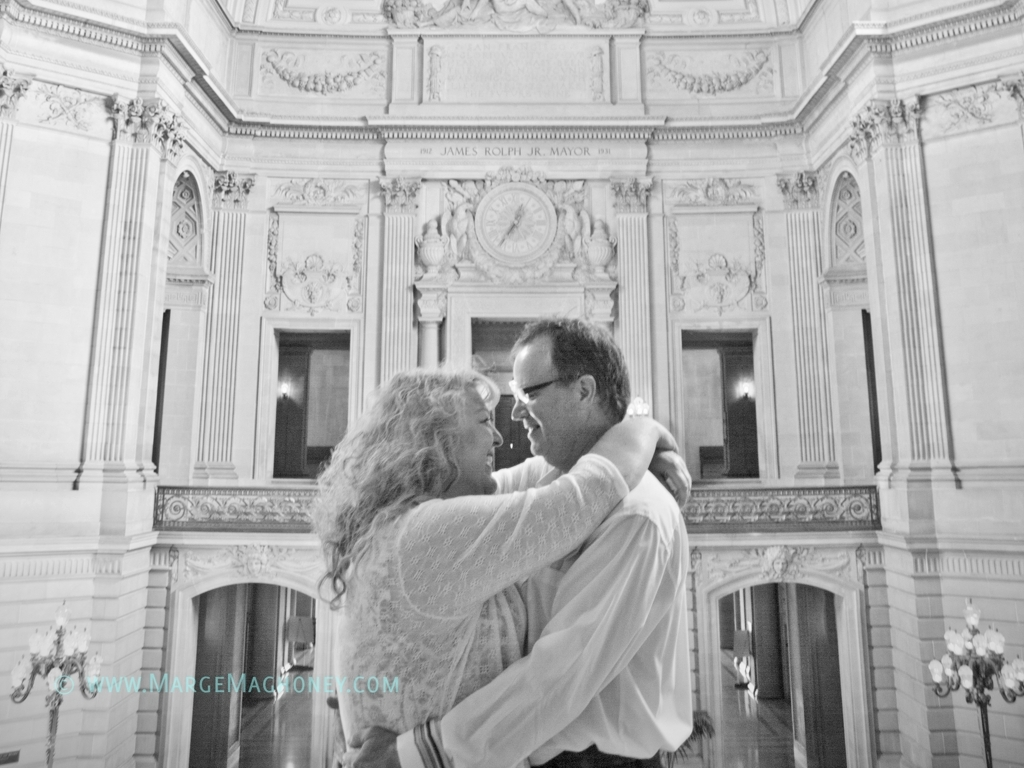How would you describe the overall clarity of this image? A. Extremely sharp B. Blurry C. Moderate The overall clarity of the image can best be described as moderate, option C. While the image is not sharply focused, the details are clear enough to discern the expression and emotions of the couple, as well as the architectural details in the background. The soft focus lends a dreamy quality to the photograph, highlighting the intimate moment between the two individuals without the distraction of overly sharp details. 